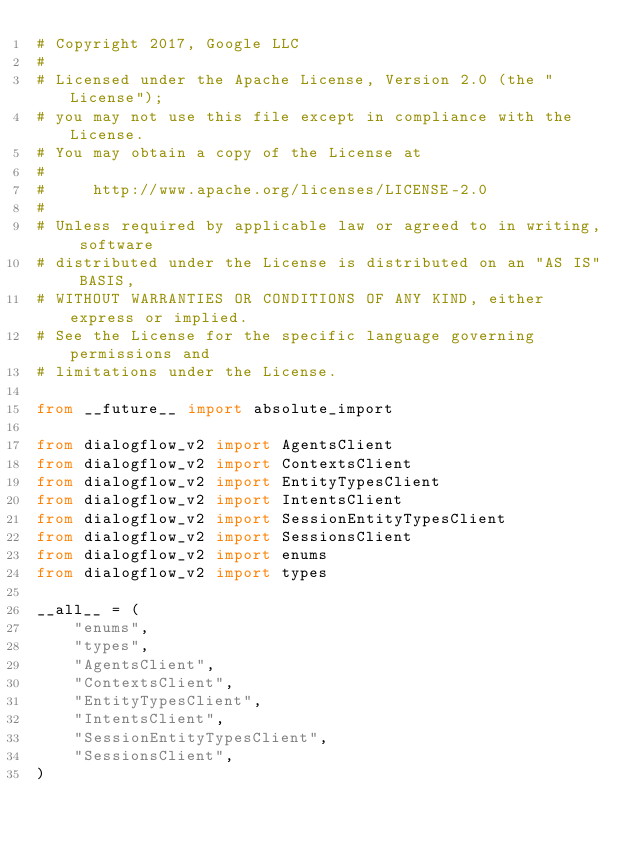<code> <loc_0><loc_0><loc_500><loc_500><_Python_># Copyright 2017, Google LLC
#
# Licensed under the Apache License, Version 2.0 (the "License");
# you may not use this file except in compliance with the License.
# You may obtain a copy of the License at
#
#     http://www.apache.org/licenses/LICENSE-2.0
#
# Unless required by applicable law or agreed to in writing, software
# distributed under the License is distributed on an "AS IS" BASIS,
# WITHOUT WARRANTIES OR CONDITIONS OF ANY KIND, either express or implied.
# See the License for the specific language governing permissions and
# limitations under the License.

from __future__ import absolute_import

from dialogflow_v2 import AgentsClient
from dialogflow_v2 import ContextsClient
from dialogflow_v2 import EntityTypesClient
from dialogflow_v2 import IntentsClient
from dialogflow_v2 import SessionEntityTypesClient
from dialogflow_v2 import SessionsClient
from dialogflow_v2 import enums
from dialogflow_v2 import types

__all__ = (
    "enums",
    "types",
    "AgentsClient",
    "ContextsClient",
    "EntityTypesClient",
    "IntentsClient",
    "SessionEntityTypesClient",
    "SessionsClient",
)
</code> 